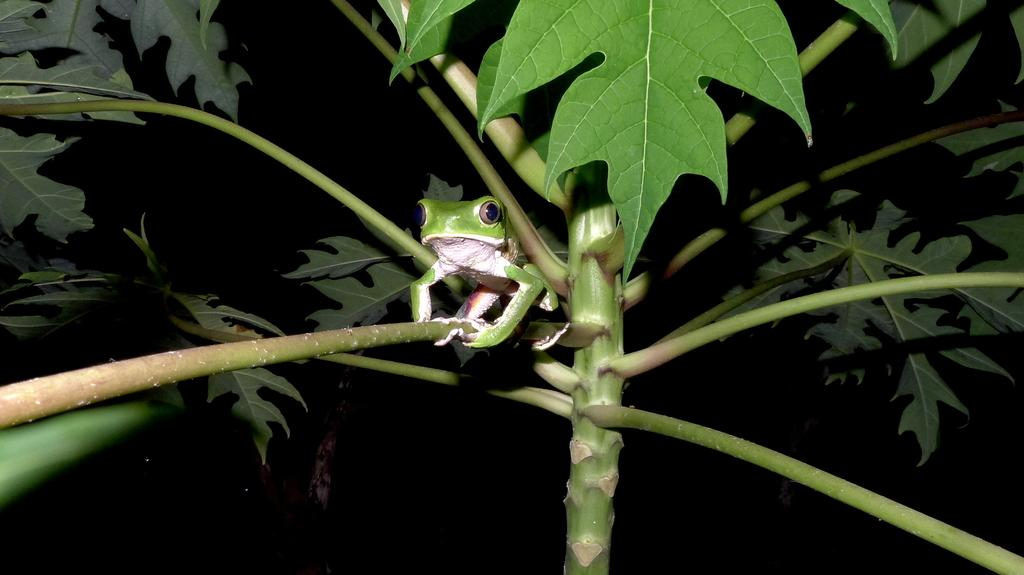What is present in the image? There is a plant in the image. Is there anything else on the plant? Yes, there is a frog on the plant. What can be observed about the background of the image? The background of the image is dark. What is the frog feeling ashamed about in the image? There is no indication in the image that the frog is feeling any shame, as emotions cannot be determined from a still image. 